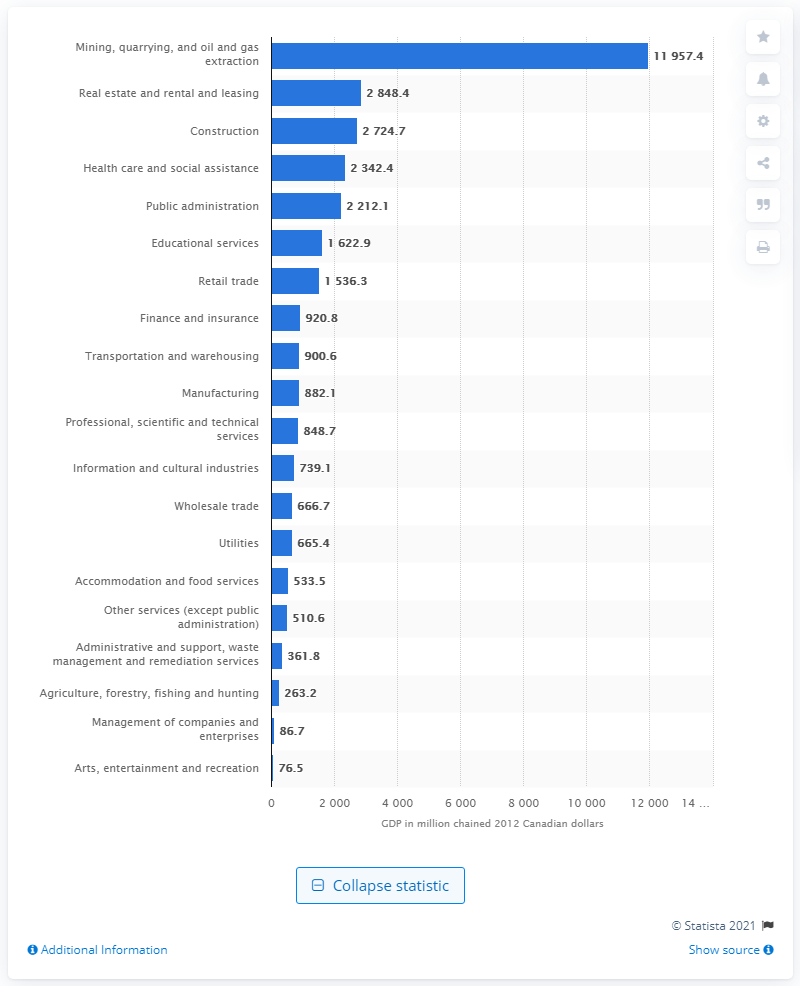Mention a couple of crucial points in this snapshot. In 2012, the Gross Domestic Product (GDP) of the construction industry in Newfoundland and Labrador was approximately 2724.7 million Canadian dollars. 